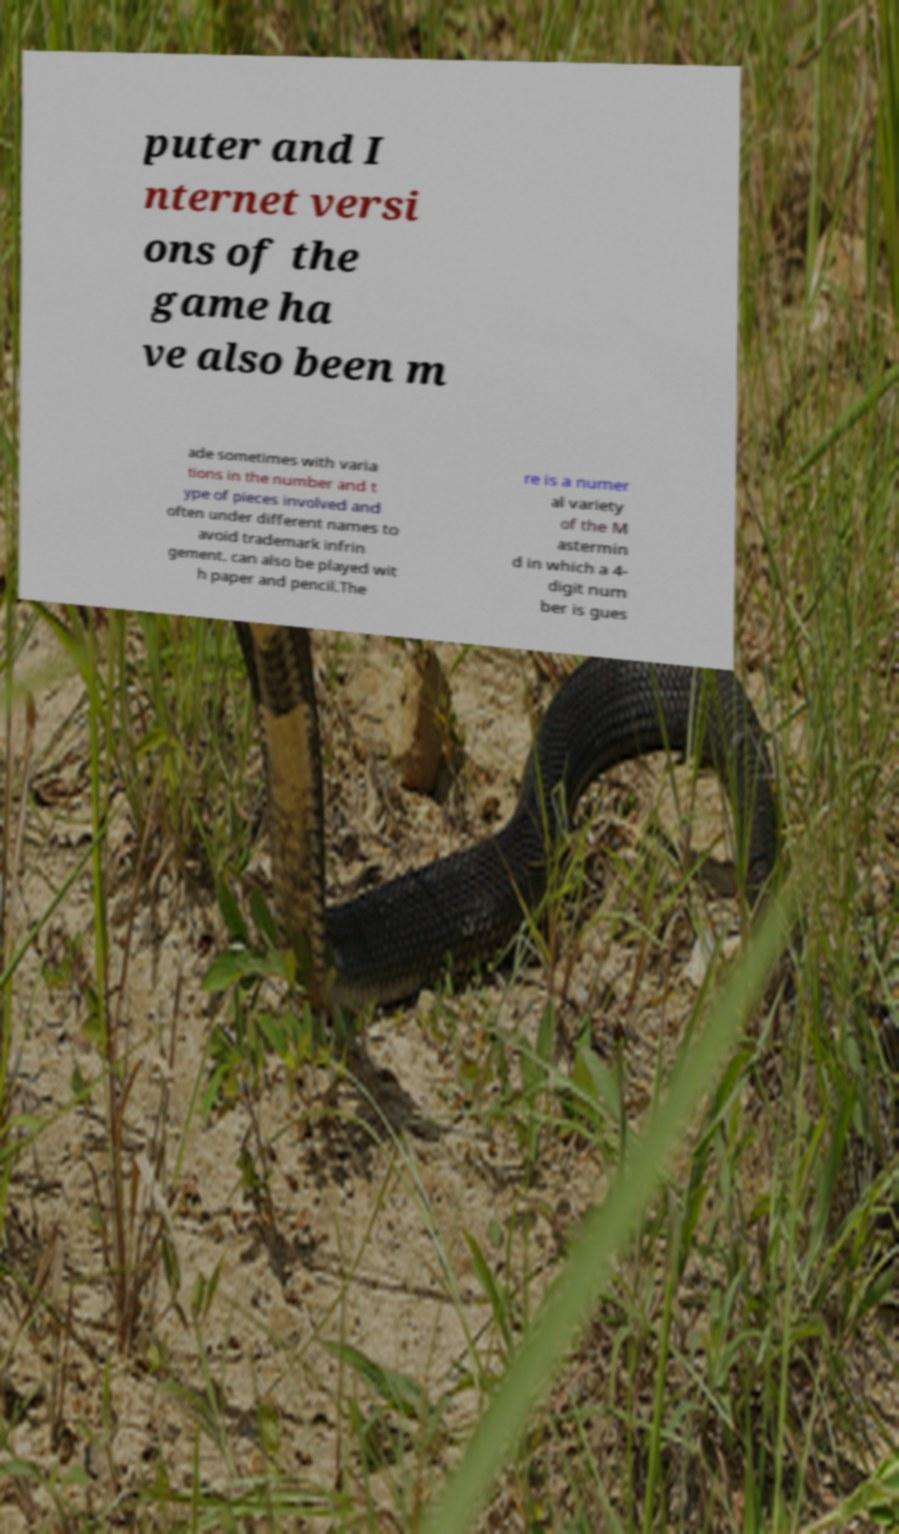For documentation purposes, I need the text within this image transcribed. Could you provide that? puter and I nternet versi ons of the game ha ve also been m ade sometimes with varia tions in the number and t ype of pieces involved and often under different names to avoid trademark infrin gement. can also be played wit h paper and pencil.The re is a numer al variety of the M astermin d in which a 4- digit num ber is gues 